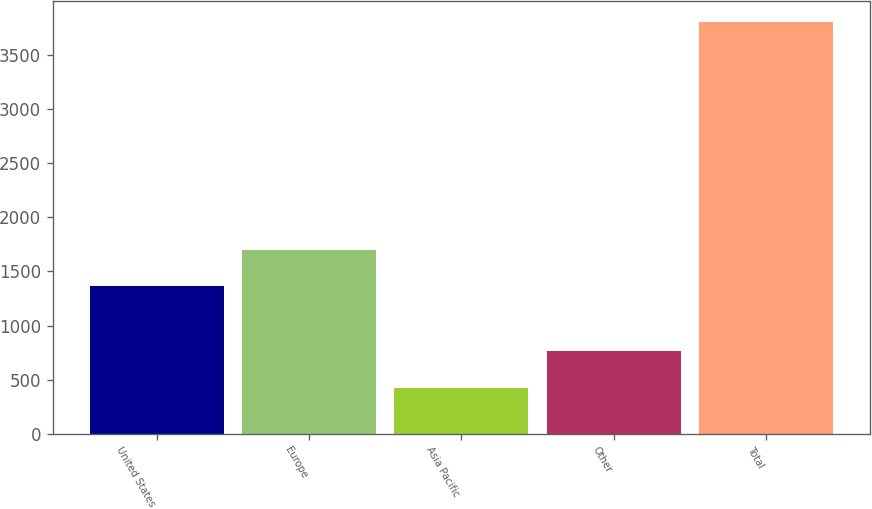<chart> <loc_0><loc_0><loc_500><loc_500><bar_chart><fcel>United States<fcel>Europe<fcel>Asia Pacific<fcel>Other<fcel>Total<nl><fcel>1363<fcel>1700.7<fcel>426<fcel>763.7<fcel>3803<nl></chart> 